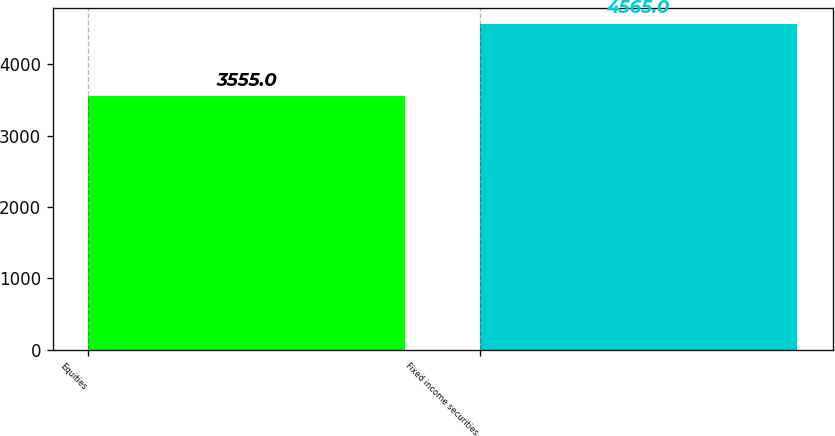<chart> <loc_0><loc_0><loc_500><loc_500><bar_chart><fcel>Equities<fcel>Fixed income securities<nl><fcel>3555<fcel>4565<nl></chart> 